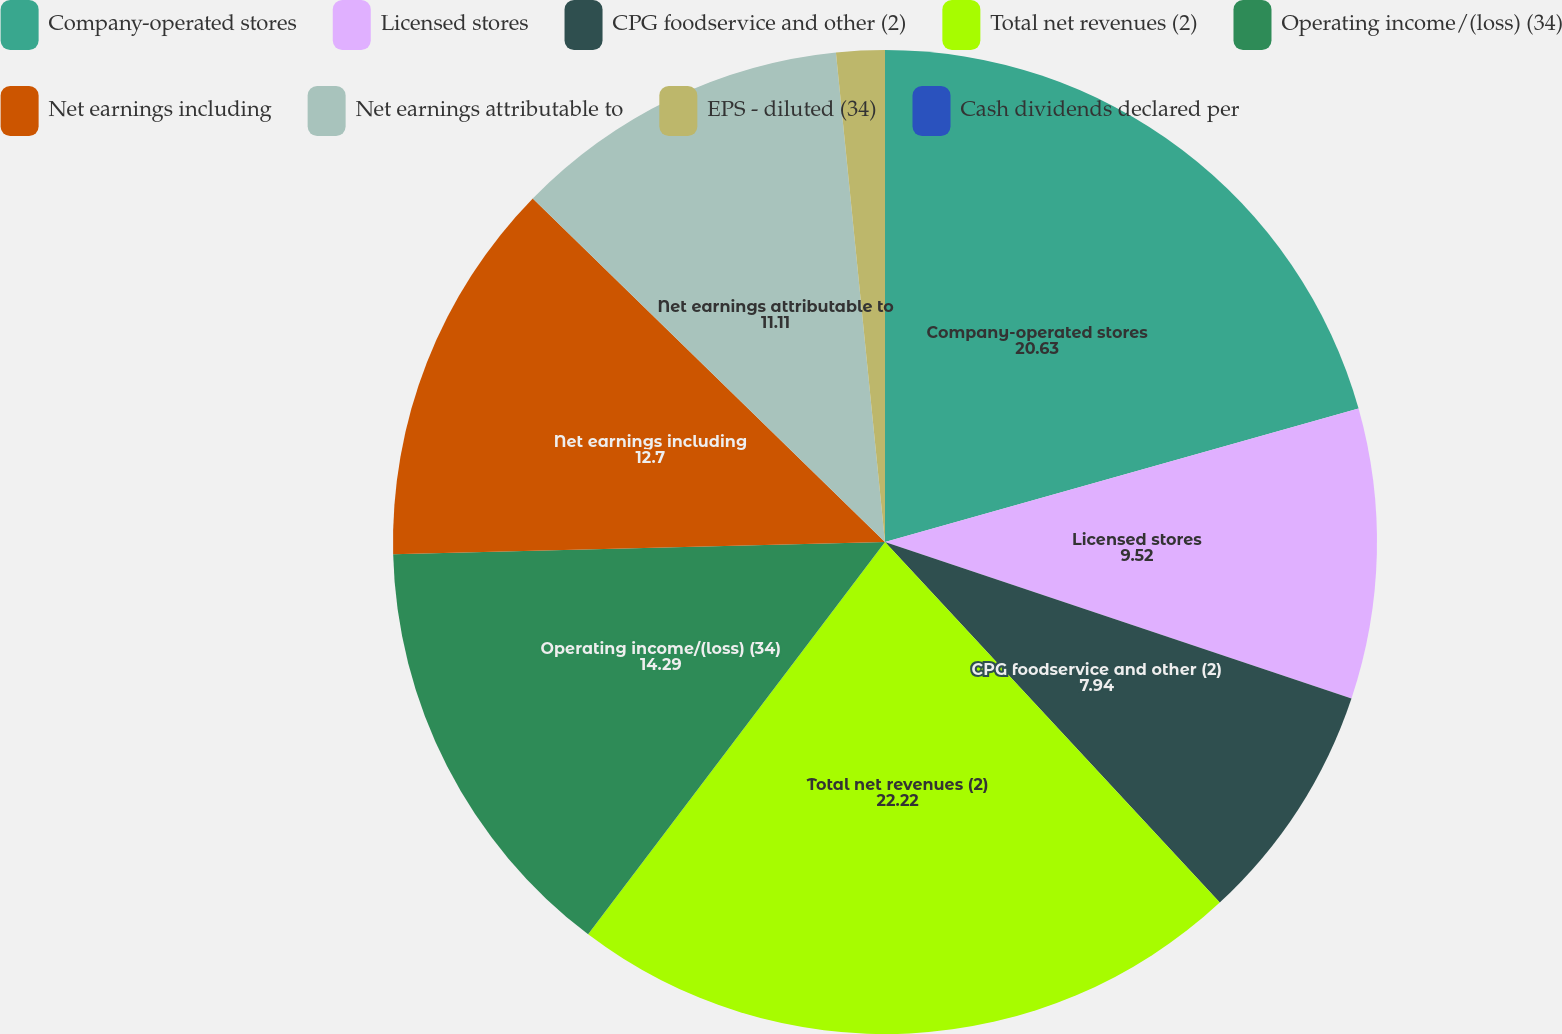Convert chart to OTSL. <chart><loc_0><loc_0><loc_500><loc_500><pie_chart><fcel>Company-operated stores<fcel>Licensed stores<fcel>CPG foodservice and other (2)<fcel>Total net revenues (2)<fcel>Operating income/(loss) (34)<fcel>Net earnings including<fcel>Net earnings attributable to<fcel>EPS - diluted (34)<fcel>Cash dividends declared per<nl><fcel>20.63%<fcel>9.52%<fcel>7.94%<fcel>22.22%<fcel>14.29%<fcel>12.7%<fcel>11.11%<fcel>1.59%<fcel>0.0%<nl></chart> 